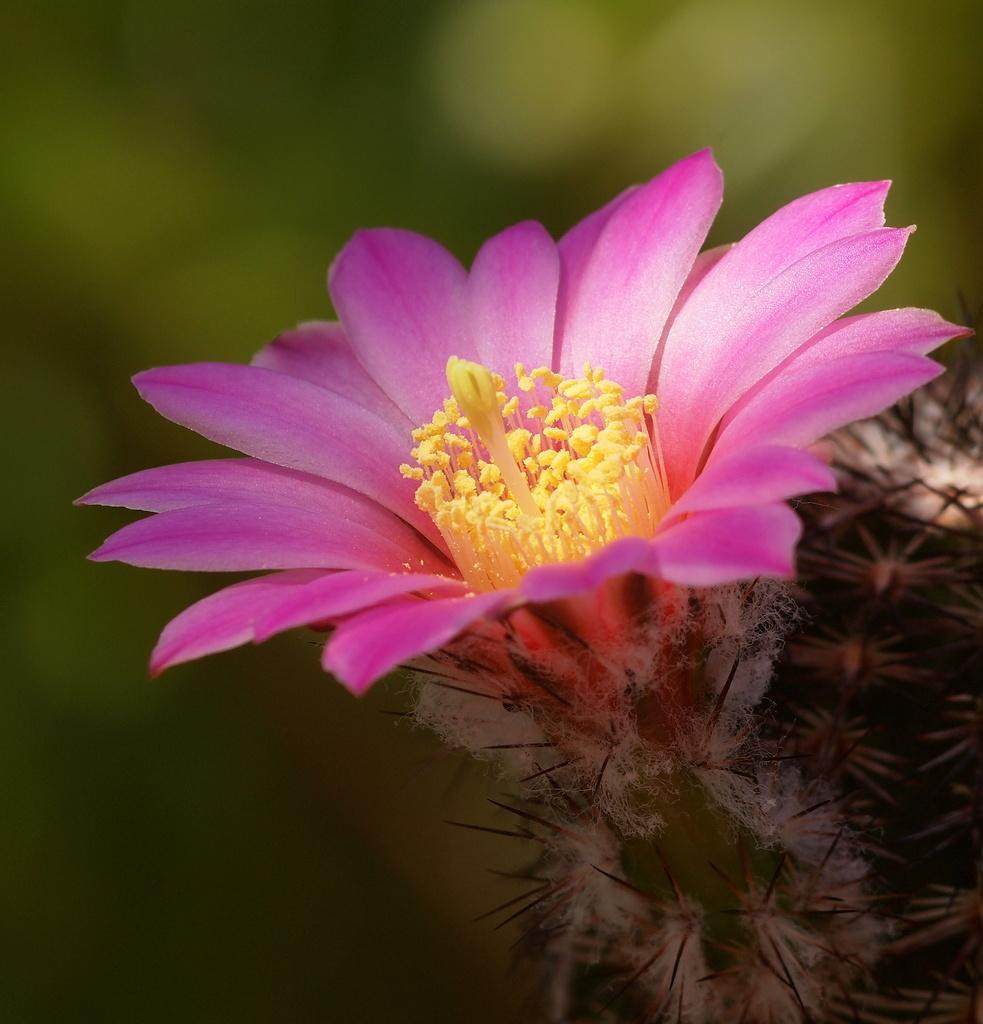Please provide a concise description of this image. In this image I can see a flower which is pink and yellow in color to a plant. I can see the green colored blurry background. 